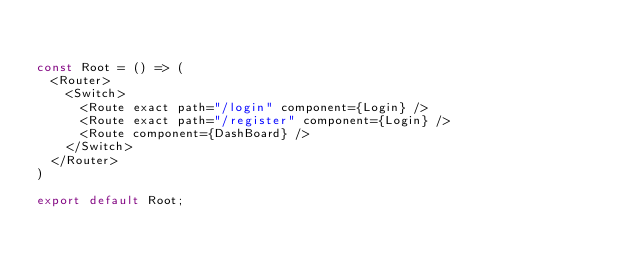Convert code to text. <code><loc_0><loc_0><loc_500><loc_500><_JavaScript_>

const Root = () => (
  <Router>
    <Switch>
      <Route exact path="/login" component={Login} />
      <Route exact path="/register" component={Login} />
      <Route component={DashBoard} />
    </Switch>
  </Router>
)

export default Root;</code> 